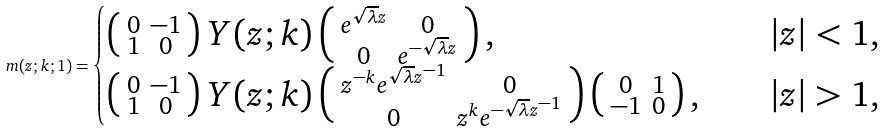Convert formula to latex. <formula><loc_0><loc_0><loc_500><loc_500>m ( z ; k ; 1 ) = \begin{cases} \left ( \begin{smallmatrix} 0 & - 1 \\ 1 & 0 \end{smallmatrix} \right ) Y ( z ; k ) \left ( \begin{smallmatrix} e ^ { \sqrt { \lambda } z } & 0 \\ 0 & e ^ { - \sqrt { \lambda } z } \end{smallmatrix} \right ) , & | z | < 1 , \\ \left ( \begin{smallmatrix} 0 & - 1 \\ 1 & 0 \end{smallmatrix} \right ) Y ( z ; k ) \left ( \begin{smallmatrix} z ^ { - k } e ^ { \sqrt { \lambda } z ^ { - 1 } } & 0 \\ 0 & z ^ { k } e ^ { - \sqrt { \lambda } z ^ { - 1 } } \end{smallmatrix} \right ) \left ( \begin{smallmatrix} 0 & 1 \\ - 1 & 0 \end{smallmatrix} \right ) , \quad & | z | > 1 , \end{cases}</formula> 